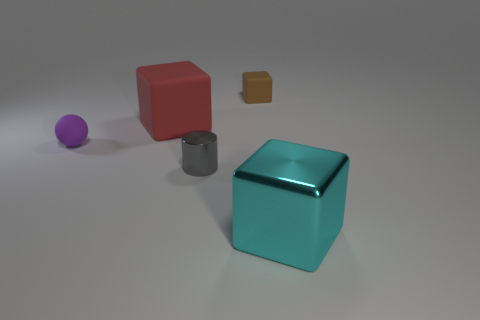Add 3 large red metallic objects. How many objects exist? 8 Subtract all spheres. How many objects are left? 4 Subtract 0 cyan spheres. How many objects are left? 5 Subtract all brown matte things. Subtract all brown matte cubes. How many objects are left? 3 Add 1 small gray objects. How many small gray objects are left? 2 Add 3 cyan shiny blocks. How many cyan shiny blocks exist? 4 